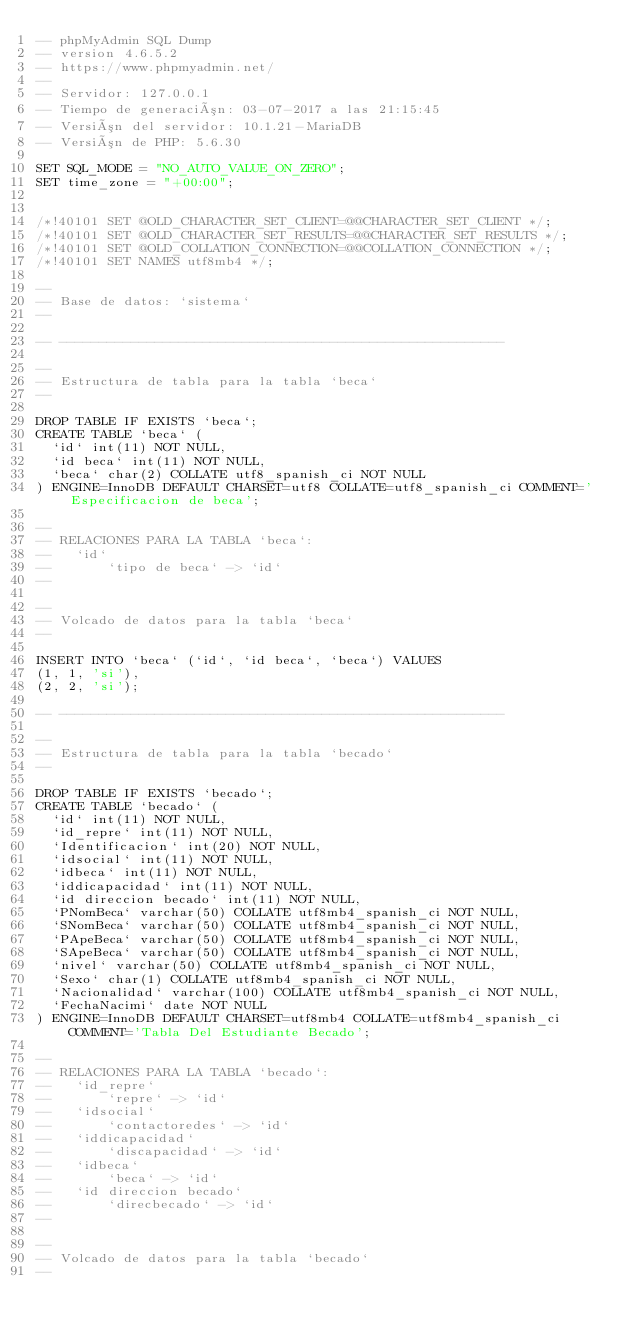<code> <loc_0><loc_0><loc_500><loc_500><_SQL_>-- phpMyAdmin SQL Dump
-- version 4.6.5.2
-- https://www.phpmyadmin.net/
--
-- Servidor: 127.0.0.1
-- Tiempo de generación: 03-07-2017 a las 21:15:45
-- Versión del servidor: 10.1.21-MariaDB
-- Versión de PHP: 5.6.30

SET SQL_MODE = "NO_AUTO_VALUE_ON_ZERO";
SET time_zone = "+00:00";


/*!40101 SET @OLD_CHARACTER_SET_CLIENT=@@CHARACTER_SET_CLIENT */;
/*!40101 SET @OLD_CHARACTER_SET_RESULTS=@@CHARACTER_SET_RESULTS */;
/*!40101 SET @OLD_COLLATION_CONNECTION=@@COLLATION_CONNECTION */;
/*!40101 SET NAMES utf8mb4 */;

--
-- Base de datos: `sistema`
--

-- --------------------------------------------------------

--
-- Estructura de tabla para la tabla `beca`
--

DROP TABLE IF EXISTS `beca`;
CREATE TABLE `beca` (
  `id` int(11) NOT NULL,
  `id beca` int(11) NOT NULL,
  `beca` char(2) COLLATE utf8_spanish_ci NOT NULL
) ENGINE=InnoDB DEFAULT CHARSET=utf8 COLLATE=utf8_spanish_ci COMMENT='Especificacion de beca';

--
-- RELACIONES PARA LA TABLA `beca`:
--   `id`
--       `tipo de beca` -> `id`
--

--
-- Volcado de datos para la tabla `beca`
--

INSERT INTO `beca` (`id`, `id beca`, `beca`) VALUES
(1, 1, 'si'),
(2, 2, 'si');

-- --------------------------------------------------------

--
-- Estructura de tabla para la tabla `becado`
--

DROP TABLE IF EXISTS `becado`;
CREATE TABLE `becado` (
  `id` int(11) NOT NULL,
  `id_repre` int(11) NOT NULL,
  `Identificacion` int(20) NOT NULL,
  `idsocial` int(11) NOT NULL,
  `idbeca` int(11) NOT NULL,
  `iddicapacidad` int(11) NOT NULL,
  `id direccion becado` int(11) NOT NULL,
  `PNomBeca` varchar(50) COLLATE utf8mb4_spanish_ci NOT NULL,
  `SNomBeca` varchar(50) COLLATE utf8mb4_spanish_ci NOT NULL,
  `PApeBeca` varchar(50) COLLATE utf8mb4_spanish_ci NOT NULL,
  `SApeBeca` varchar(50) COLLATE utf8mb4_spanish_ci NOT NULL,
  `nivel` varchar(50) COLLATE utf8mb4_spanish_ci NOT NULL,
  `Sexo` char(1) COLLATE utf8mb4_spanish_ci NOT NULL,
  `Nacionalidad` varchar(100) COLLATE utf8mb4_spanish_ci NOT NULL,
  `FechaNacimi` date NOT NULL
) ENGINE=InnoDB DEFAULT CHARSET=utf8mb4 COLLATE=utf8mb4_spanish_ci COMMENT='Tabla Del Estudiante Becado';

--
-- RELACIONES PARA LA TABLA `becado`:
--   `id_repre`
--       `repre` -> `id`
--   `idsocial`
--       `contactoredes` -> `id`
--   `iddicapacidad`
--       `discapacidad` -> `id`
--   `idbeca`
--       `beca` -> `id`
--   `id direccion becado`
--       `direcbecado` -> `id`
--

--
-- Volcado de datos para la tabla `becado`
--
</code> 